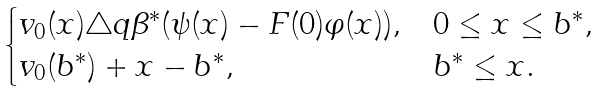<formula> <loc_0><loc_0><loc_500><loc_500>\begin{cases} v _ { 0 } ( x ) \triangle q \beta ^ { * } ( \psi ( x ) - F ( 0 ) \varphi ( x ) ) , & 0 \leq x \leq b ^ { * } , \\ v _ { 0 } ( b ^ { * } ) + x - b ^ { * } , & b ^ { * } \leq x . \end{cases}</formula> 